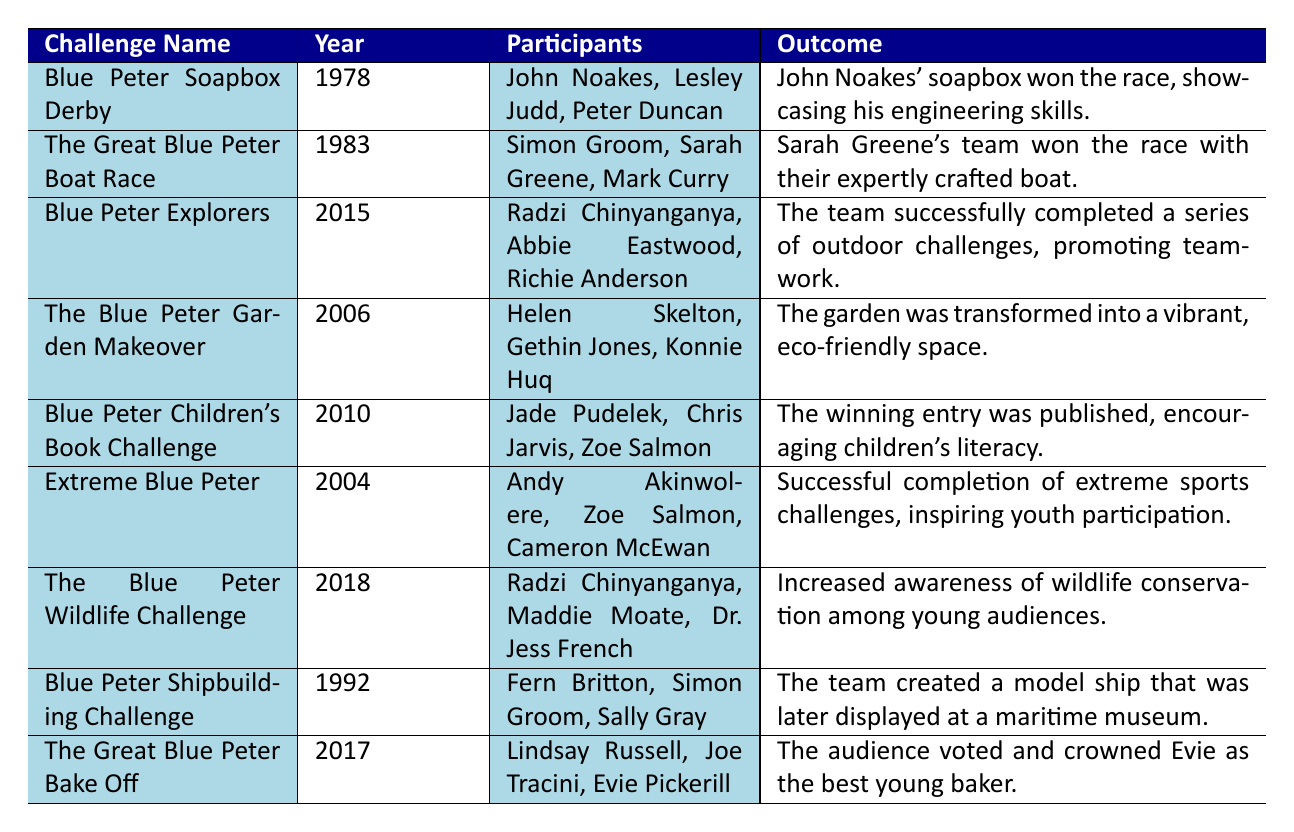What year did the Blue Peter Soapbox Derby take place? The table indicates that the Blue Peter Soapbox Derby occurred in the year 1978.
Answer: 1978 Who were the participants in the Extreme Blue Peter challenge? According to the table, the participants in the Extreme Blue Peter challenge were Andy Akinwolere, Zoe Salmon, and Cameron McEwan.
Answer: Andy Akinwolere, Zoe Salmon, Cameron McEwan What was the outcome of the 2010 Blue Peter Children's Book Challenge? The table states that the winning entry of the Blue Peter Children's Book Challenge was published, which encouraged children's literacy.
Answer: The winning entry was published, encouraging children's literacy How many challenges took place before the year 2000? The table shows 5 challenges that occurred before the year 2000: Blue Peter Soapbox Derby (1978), The Great Blue Peter Boat Race (1983), Blue Peter Shipbuilding Challenge (1992), Extreme Blue Peter (2004), and The Blue Peter Garden Makeover (2006). The total count is 4.
Answer: 4 Was the outcome of the Blue Peter Wildlife Challenge positive for wildlife conservation? The outcome of the Blue Peter Wildlife Challenge was to increase awareness of wildlife conservation among young audiences, which indicates a positive impact.
Answer: Yes What were the details of The Great Blue Peter Bake Off? The table indicates that The Great Blue Peter Bake Off involved young bakers from around the country showcasing their skills in a baking competition, with the audience voting to crown the best young baker, Evie.
Answer: Young bakers showcased their skills in a competition, Evie was crowned best baker Which challenge had participants engaged in outdoor activities such as climbing? The challenge that involved outdoor activities such as climbing was Blue Peter Explorers in 2015, where the participants completed a series of adventurous activities.
Answer: Blue Peter Explorers How many participants took part in the Blue Peter Garden Makeover? In the Blue Peter Garden Makeover, there were 3 participants: Helen Skelton, Gethin Jones, and Konnie Huq.
Answer: 3 What is the average year of the challenges listed? To find the average year, sum the years (1978 + 1983 + 1992 + 2004 + 2006 + 2010 + 2015 + 2017 + 2018) which equals 1793. There are 9 challenges, so the average is 1793 / 9 = 199.22, rounded to 1994.
Answer: 1994 